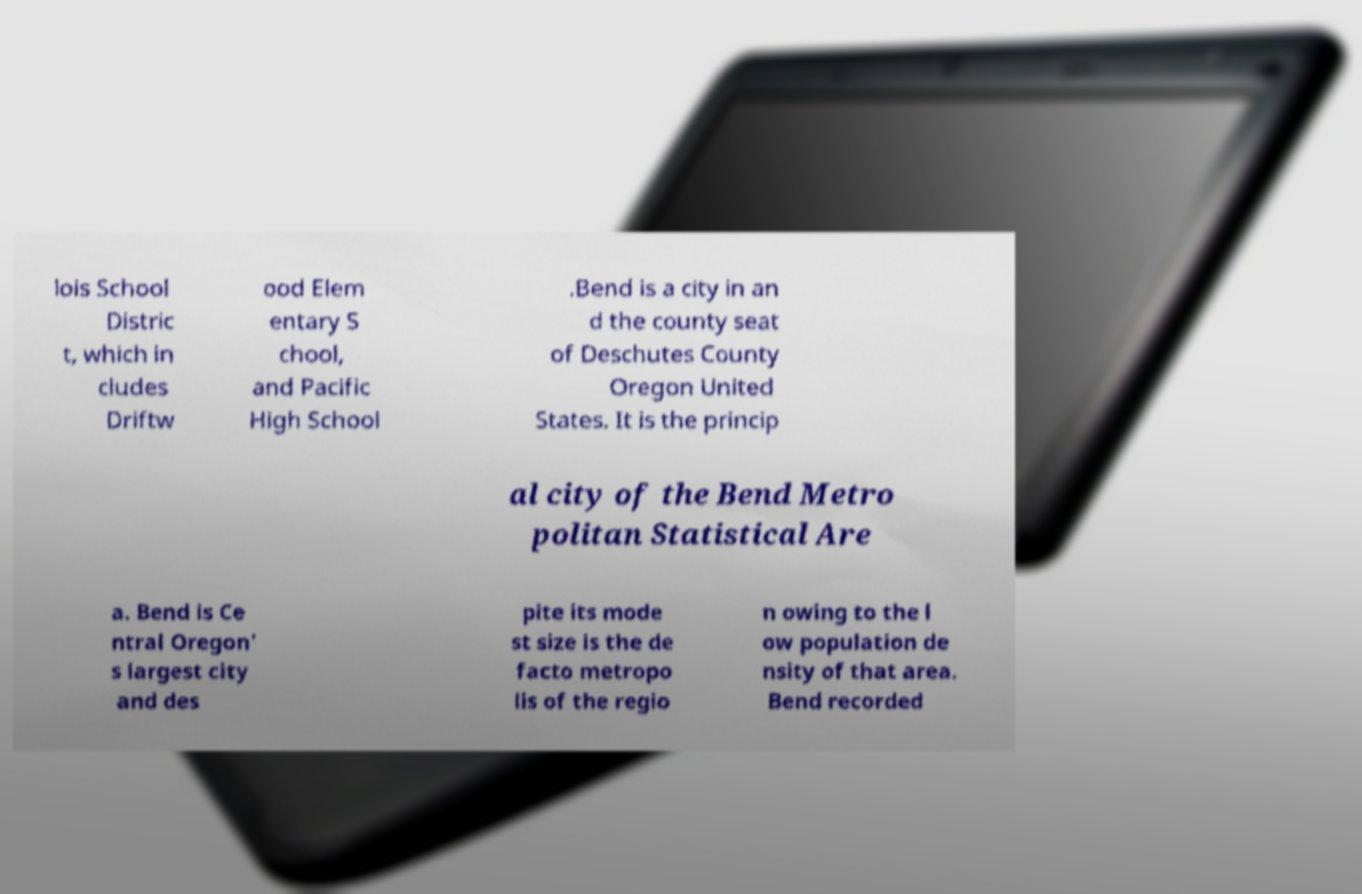Could you assist in decoding the text presented in this image and type it out clearly? lois School Distric t, which in cludes Driftw ood Elem entary S chool, and Pacific High School .Bend is a city in an d the county seat of Deschutes County Oregon United States. It is the princip al city of the Bend Metro politan Statistical Are a. Bend is Ce ntral Oregon' s largest city and des pite its mode st size is the de facto metropo lis of the regio n owing to the l ow population de nsity of that area. Bend recorded 